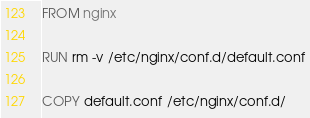Convert code to text. <code><loc_0><loc_0><loc_500><loc_500><_Dockerfile_>FROM nginx

RUN rm -v /etc/nginx/conf.d/default.conf

COPY default.conf /etc/nginx/conf.d/
</code> 